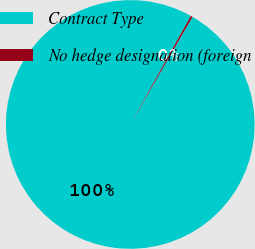Convert chart. <chart><loc_0><loc_0><loc_500><loc_500><pie_chart><fcel>Contract Type<fcel>No hedge designation (foreign<nl><fcel>99.75%<fcel>0.25%<nl></chart> 